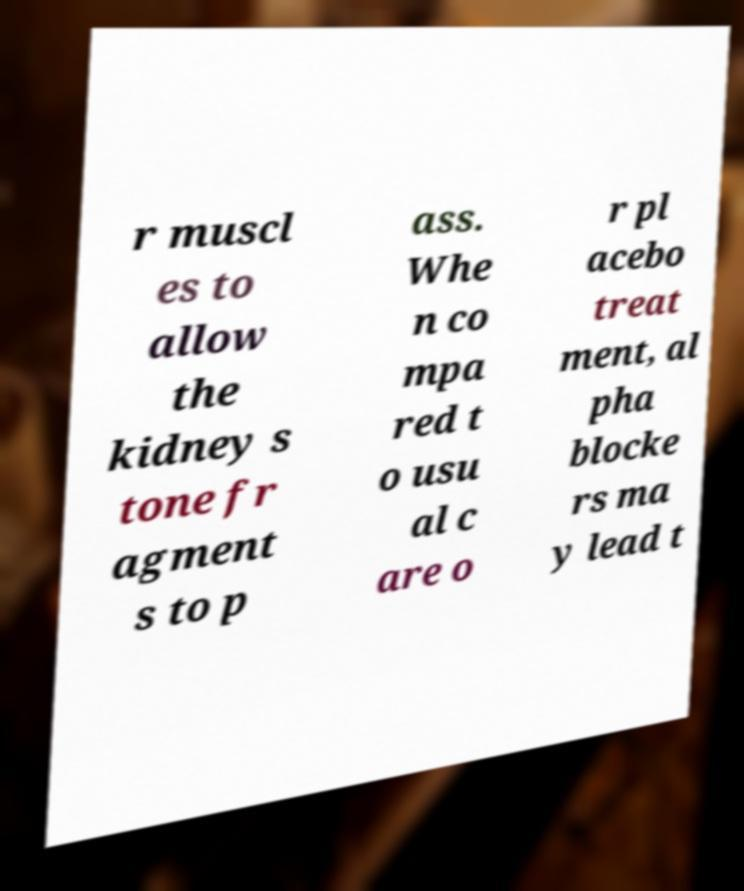For documentation purposes, I need the text within this image transcribed. Could you provide that? r muscl es to allow the kidney s tone fr agment s to p ass. Whe n co mpa red t o usu al c are o r pl acebo treat ment, al pha blocke rs ma y lead t 